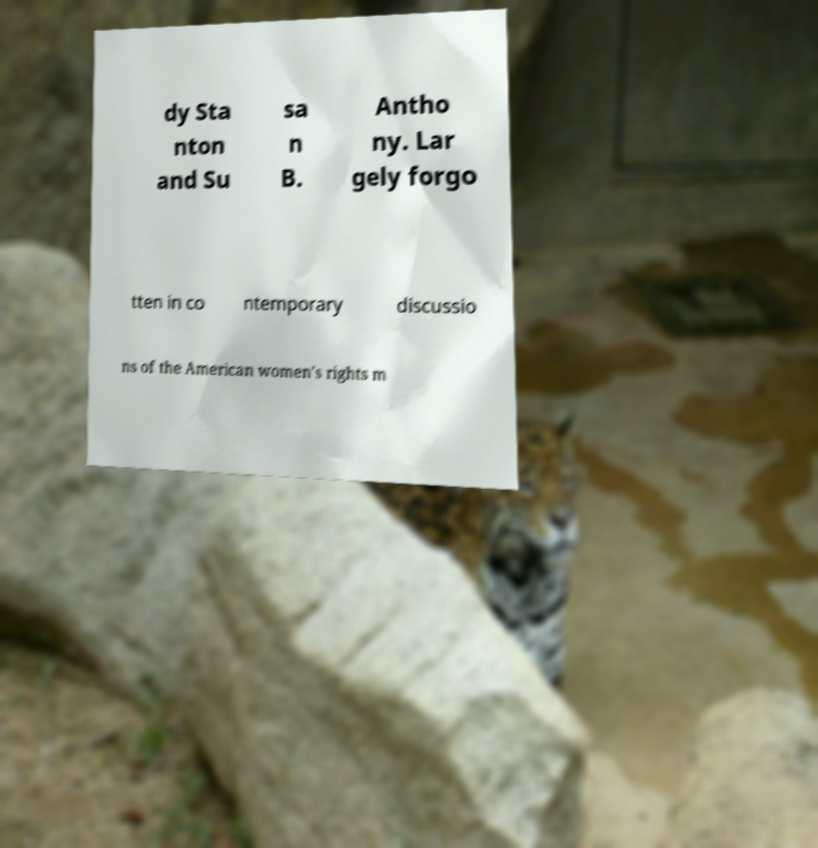There's text embedded in this image that I need extracted. Can you transcribe it verbatim? dy Sta nton and Su sa n B. Antho ny. Lar gely forgo tten in co ntemporary discussio ns of the American women's rights m 